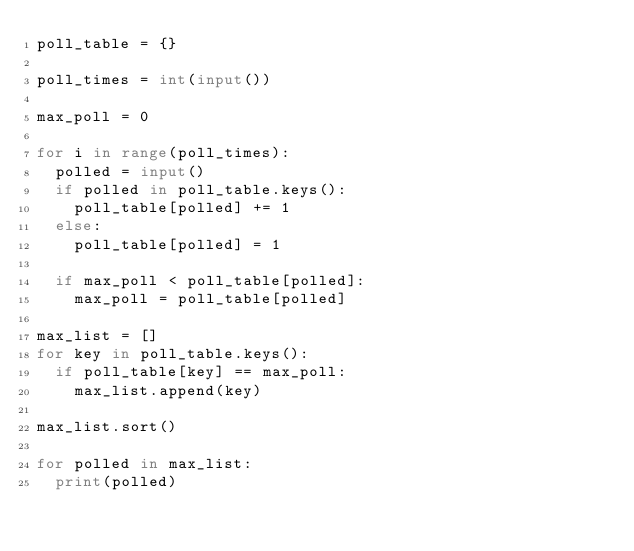Convert code to text. <code><loc_0><loc_0><loc_500><loc_500><_Python_>poll_table = {}

poll_times = int(input())

max_poll = 0

for i in range(poll_times):
  polled = input()
  if polled in poll_table.keys():
    poll_table[polled] += 1
  else:
    poll_table[polled] = 1

  if max_poll < poll_table[polled]:
    max_poll = poll_table[polled]

max_list = []
for key in poll_table.keys():
  if poll_table[key] == max_poll:
    max_list.append(key)

max_list.sort()

for polled in max_list:
  print(polled)</code> 